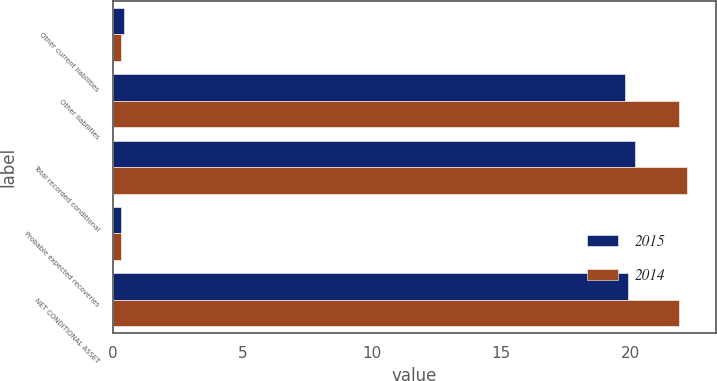<chart> <loc_0><loc_0><loc_500><loc_500><stacked_bar_chart><ecel><fcel>Other current liabilities<fcel>Other liabilities<fcel>Total recorded conditional<fcel>Probable expected recoveries<fcel>NET CONDITIONAL ASSET<nl><fcel>2015<fcel>0.4<fcel>19.8<fcel>20.2<fcel>0.3<fcel>19.9<nl><fcel>2014<fcel>0.3<fcel>21.9<fcel>22.2<fcel>0.3<fcel>21.9<nl></chart> 